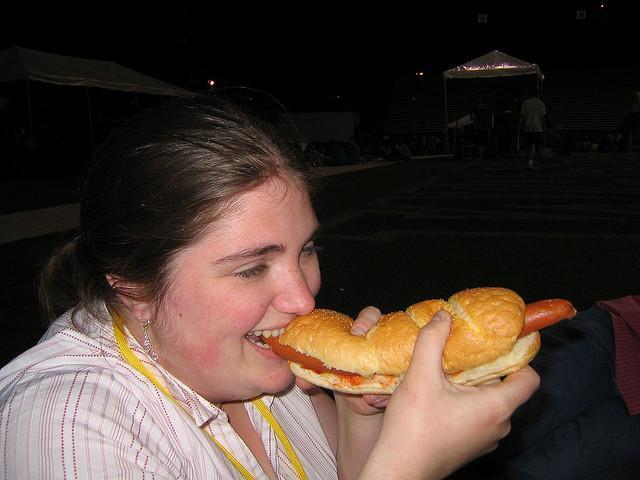How many red headlights does the train have?
Give a very brief answer. 0. 